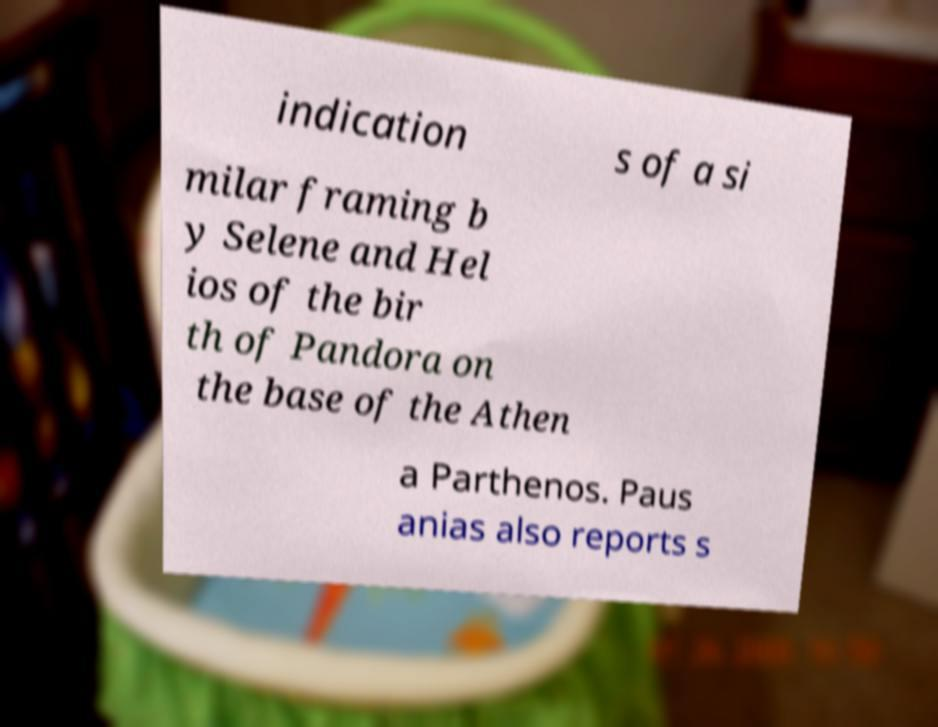Could you assist in decoding the text presented in this image and type it out clearly? indication s of a si milar framing b y Selene and Hel ios of the bir th of Pandora on the base of the Athen a Parthenos. Paus anias also reports s 